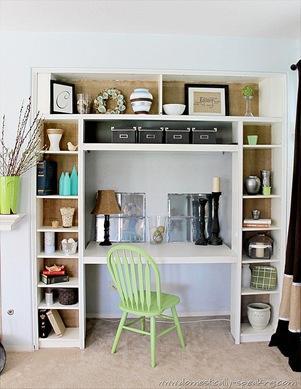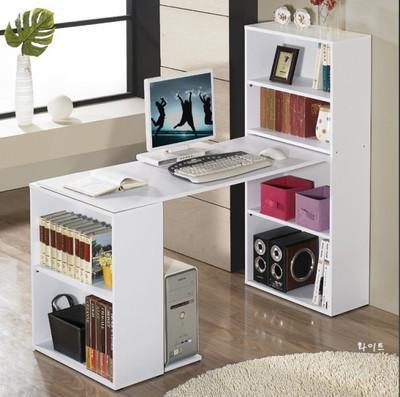The first image is the image on the left, the second image is the image on the right. For the images displayed, is the sentence "An image shows a white storage piece with its taller end flush against a wall and a computer atop the desk part." factually correct? Answer yes or no. Yes. The first image is the image on the left, the second image is the image on the right. Considering the images on both sides, is "In one image a white desk and shelf unit has one narrow end against a wall, while the other image is a white shelf unit flush to the wall with a chair in front of it." valid? Answer yes or no. Yes. 